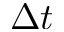<formula> <loc_0><loc_0><loc_500><loc_500>\Delta t</formula> 